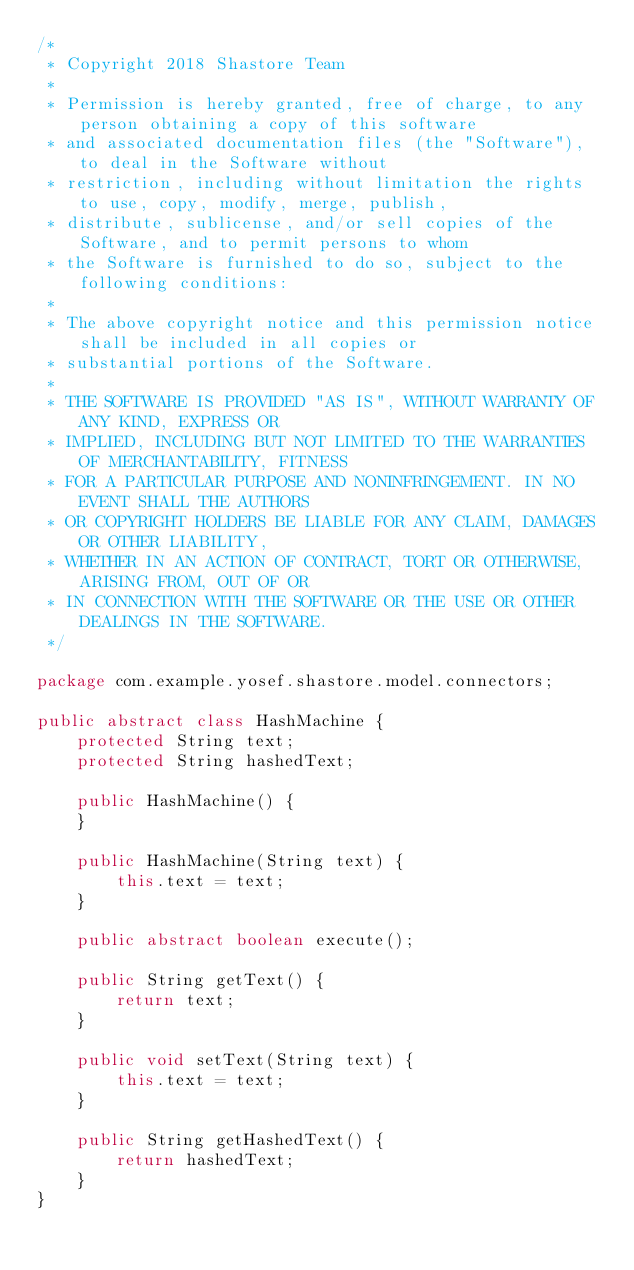<code> <loc_0><loc_0><loc_500><loc_500><_Java_>/*
 * Copyright 2018 Shastore Team
 *
 * Permission is hereby granted, free of charge, to any person obtaining a copy of this software
 * and associated documentation files (the "Software"), to deal in the Software without
 * restriction, including without limitation the rights to use, copy, modify, merge, publish,
 * distribute, sublicense, and/or sell copies of the Software, and to permit persons to whom
 * the Software is furnished to do so, subject to the following conditions:
 *
 * The above copyright notice and this permission notice shall be included in all copies or
 * substantial portions of the Software.
 *
 * THE SOFTWARE IS PROVIDED "AS IS", WITHOUT WARRANTY OF ANY KIND, EXPRESS OR
 * IMPLIED, INCLUDING BUT NOT LIMITED TO THE WARRANTIES OF MERCHANTABILITY, FITNESS
 * FOR A PARTICULAR PURPOSE AND NONINFRINGEMENT. IN NO EVENT SHALL THE AUTHORS
 * OR COPYRIGHT HOLDERS BE LIABLE FOR ANY CLAIM, DAMAGES OR OTHER LIABILITY,
 * WHETHER IN AN ACTION OF CONTRACT, TORT OR OTHERWISE, ARISING FROM, OUT OF OR
 * IN CONNECTION WITH THE SOFTWARE OR THE USE OR OTHER DEALINGS IN THE SOFTWARE.
 */

package com.example.yosef.shastore.model.connectors;

public abstract class HashMachine {
    protected String text;
    protected String hashedText;

    public HashMachine() {
    }

    public HashMachine(String text) {
        this.text = text;
    }

    public abstract boolean execute();

    public String getText() {
        return text;
    }

    public void setText(String text) {
        this.text = text;
    }

    public String getHashedText() {
        return hashedText;
    }
}
</code> 